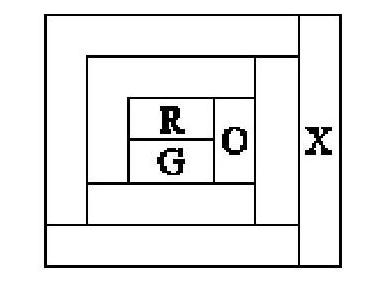Can you provide some strategies to approach coloring a diagram like this with the given constraints? Certainly! When coloring a diagram with constraints, such as different colors for adjacent areas, it's helpful to start by filling in the areas that have the fewest options first, and expanding outwards. It's also a good strategy to use a process of elimination to reduce available choices, and to keep in mind the overall balance in color distribution to avoid running out of usable colors as you progress. 